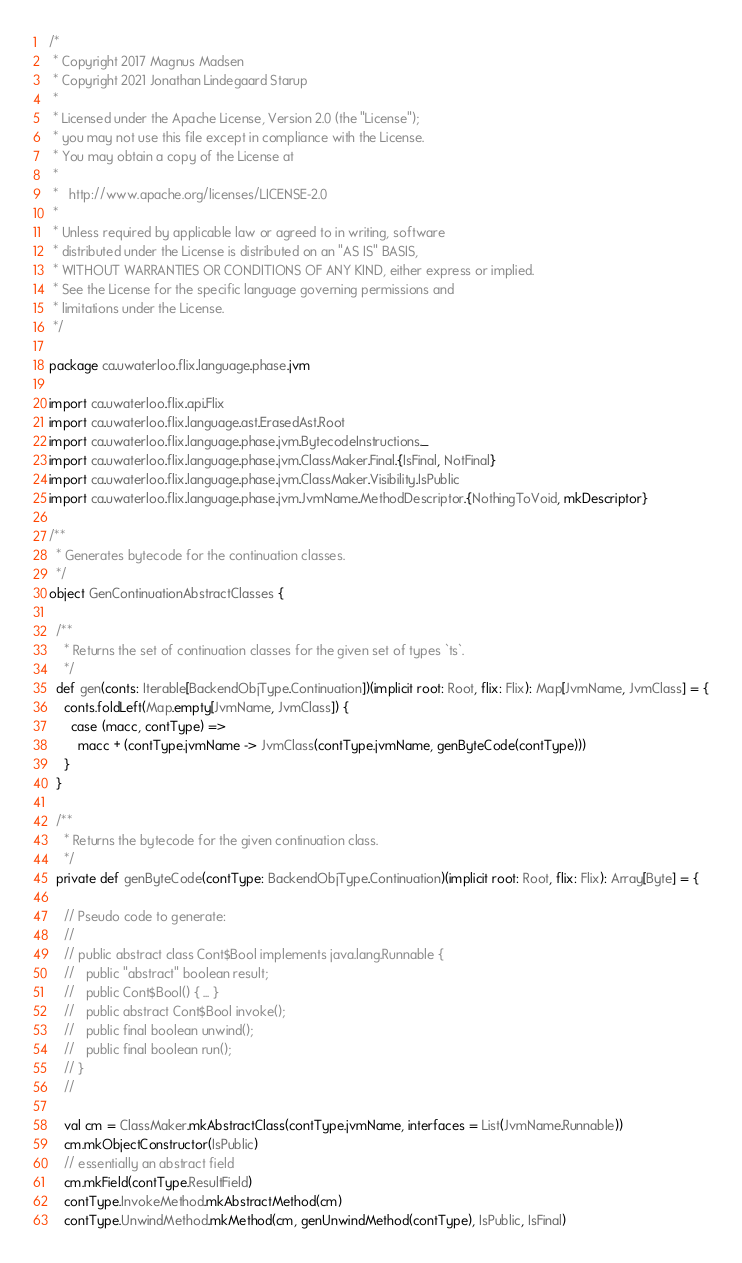<code> <loc_0><loc_0><loc_500><loc_500><_Scala_>/*
 * Copyright 2017 Magnus Madsen
 * Copyright 2021 Jonathan Lindegaard Starup
 *
 * Licensed under the Apache License, Version 2.0 (the "License");
 * you may not use this file except in compliance with the License.
 * You may obtain a copy of the License at
 *
 *   http://www.apache.org/licenses/LICENSE-2.0
 *
 * Unless required by applicable law or agreed to in writing, software
 * distributed under the License is distributed on an "AS IS" BASIS,
 * WITHOUT WARRANTIES OR CONDITIONS OF ANY KIND, either express or implied.
 * See the License for the specific language governing permissions and
 * limitations under the License.
 */

package ca.uwaterloo.flix.language.phase.jvm

import ca.uwaterloo.flix.api.Flix
import ca.uwaterloo.flix.language.ast.ErasedAst.Root
import ca.uwaterloo.flix.language.phase.jvm.BytecodeInstructions._
import ca.uwaterloo.flix.language.phase.jvm.ClassMaker.Final.{IsFinal, NotFinal}
import ca.uwaterloo.flix.language.phase.jvm.ClassMaker.Visibility.IsPublic
import ca.uwaterloo.flix.language.phase.jvm.JvmName.MethodDescriptor.{NothingToVoid, mkDescriptor}

/**
  * Generates bytecode for the continuation classes.
  */
object GenContinuationAbstractClasses {

  /**
    * Returns the set of continuation classes for the given set of types `ts`.
    */
  def gen(conts: Iterable[BackendObjType.Continuation])(implicit root: Root, flix: Flix): Map[JvmName, JvmClass] = {
    conts.foldLeft(Map.empty[JvmName, JvmClass]) {
      case (macc, contType) =>
        macc + (contType.jvmName -> JvmClass(contType.jvmName, genByteCode(contType)))
    }
  }

  /**
    * Returns the bytecode for the given continuation class.
    */
  private def genByteCode(contType: BackendObjType.Continuation)(implicit root: Root, flix: Flix): Array[Byte] = {

    // Pseudo code to generate:
    //
    // public abstract class Cont$Bool implements java.lang.Runnable {
    //   public "abstract" boolean result;
    //   public Cont$Bool() { ... }
    //   public abstract Cont$Bool invoke();
    //   public final boolean unwind();
    //   public final boolean run();
    // }
    //

    val cm = ClassMaker.mkAbstractClass(contType.jvmName, interfaces = List(JvmName.Runnable))
    cm.mkObjectConstructor(IsPublic)
    // essentially an abstract field
    cm.mkField(contType.ResultField)
    contType.InvokeMethod.mkAbstractMethod(cm)
    contType.UnwindMethod.mkMethod(cm, genUnwindMethod(contType), IsPublic, IsFinal)</code> 